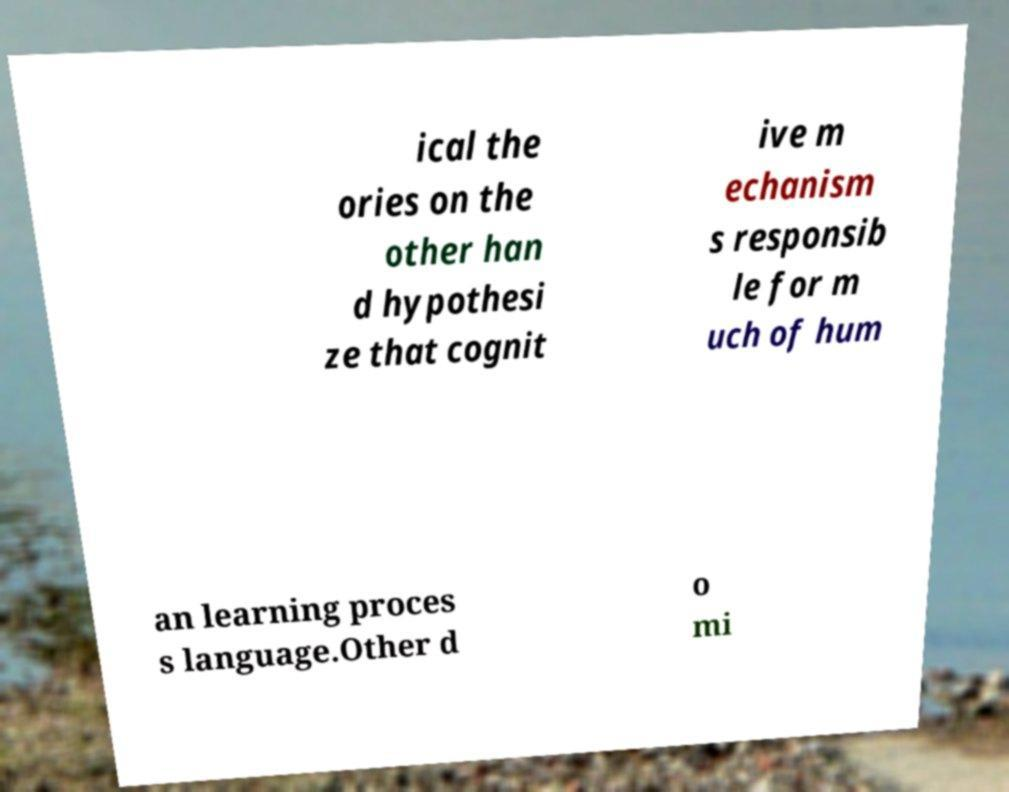Please read and relay the text visible in this image. What does it say? ical the ories on the other han d hypothesi ze that cognit ive m echanism s responsib le for m uch of hum an learning proces s language.Other d o mi 